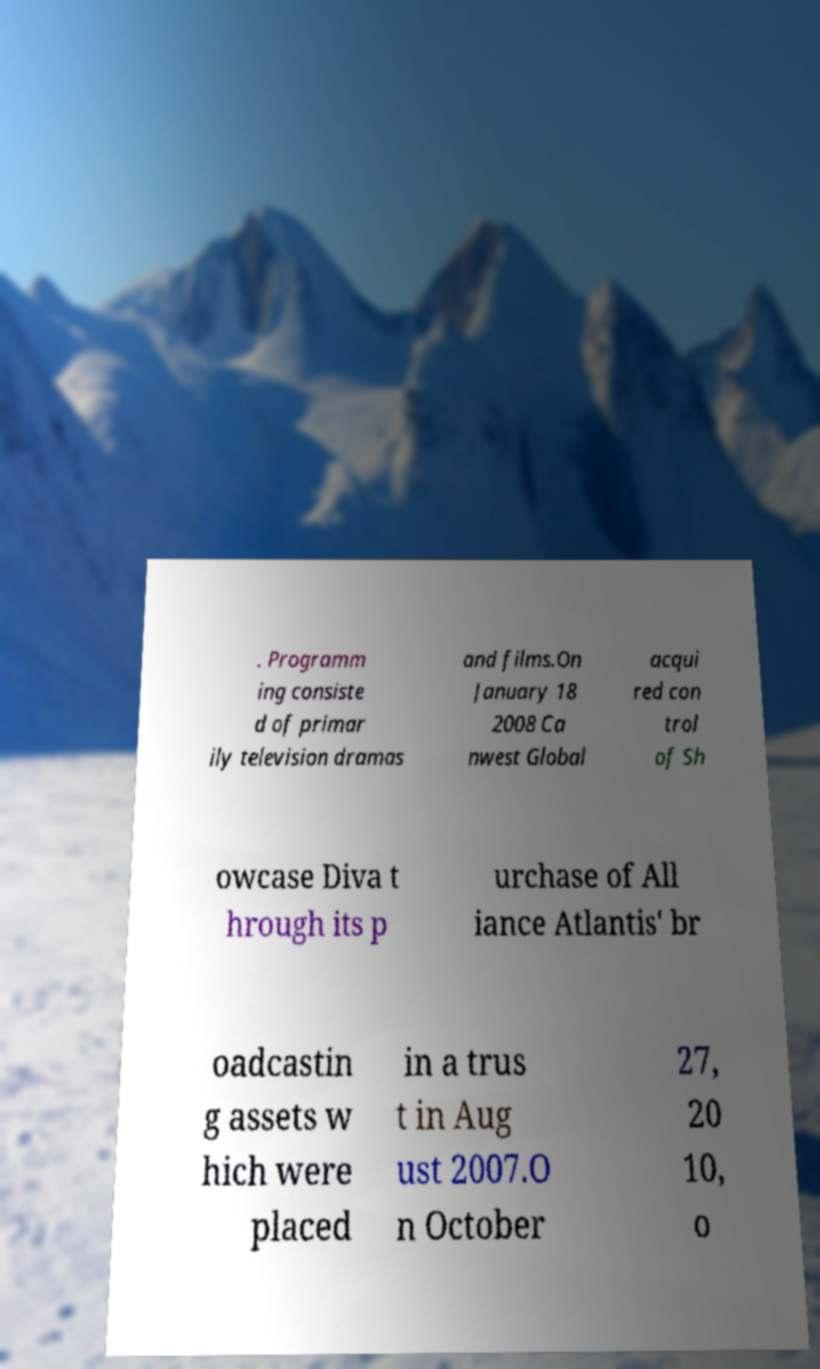Can you read and provide the text displayed in the image?This photo seems to have some interesting text. Can you extract and type it out for me? . Programm ing consiste d of primar ily television dramas and films.On January 18 2008 Ca nwest Global acqui red con trol of Sh owcase Diva t hrough its p urchase of All iance Atlantis' br oadcastin g assets w hich were placed in a trus t in Aug ust 2007.O n October 27, 20 10, o 